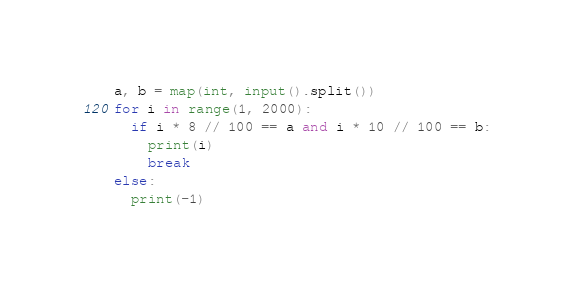<code> <loc_0><loc_0><loc_500><loc_500><_Python_>a, b = map(int, input().split())
for i in range(1, 2000):
  if i * 8 // 100 == a and i * 10 // 100 == b:
    print(i)
    break
else:
  print(-1)</code> 